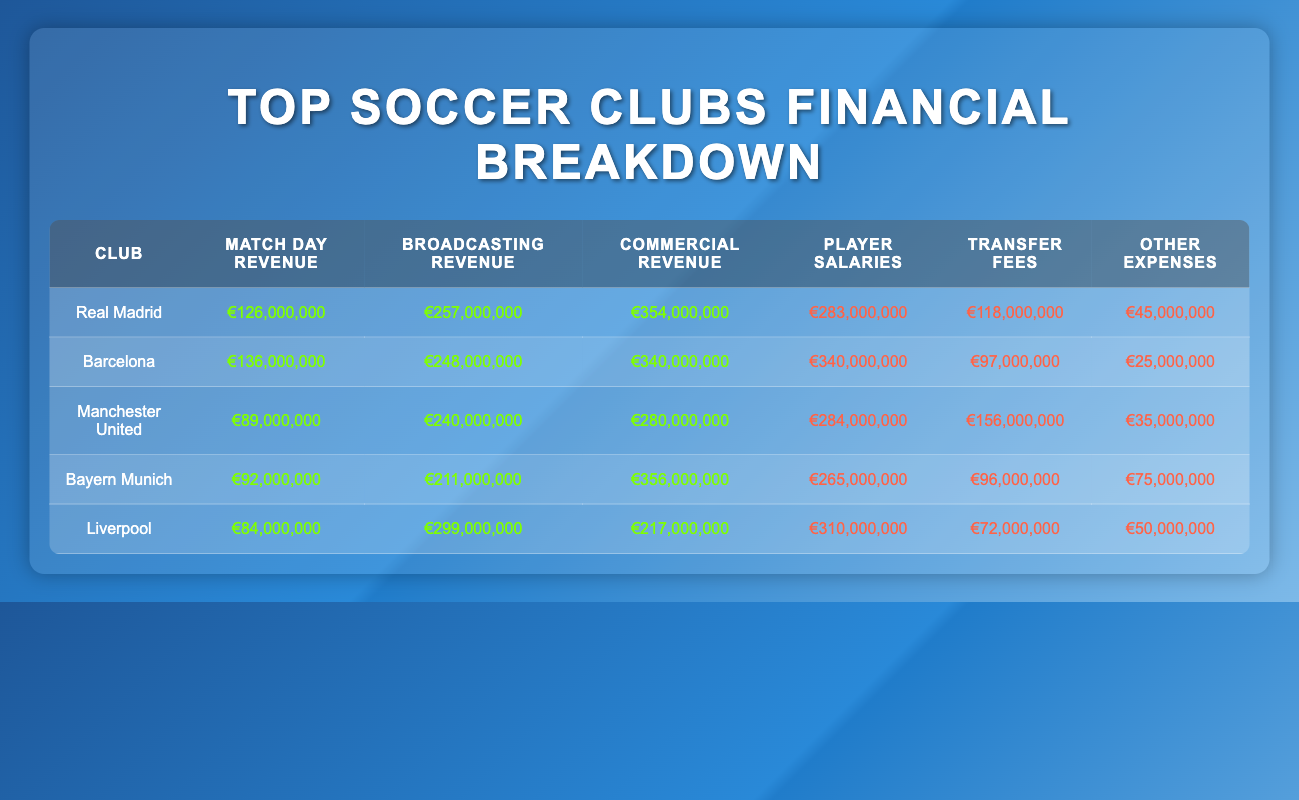What is the match day revenue for Barcelona? The table shows that Barcelona's match day revenue is listed directly under the relevant column. Looking at the row for Barcelona, the match day revenue is €136,000,000.
Answer: €136,000,000 Which club has the highest broadcasting revenue? By comparing the broadcasting revenue figures for all clubs in the table, Bayern Munich's broadcasting revenue is €211,000,000, while the others are lower: Real Madrid at €257,000,000 and Barcelona at €248,000,000. Therefore, Real Madrid has the highest broadcasting revenue.
Answer: €257,000,000 What is the total player salaries for all clubs combined? To calculate the total player salaries, we sum the player salaries of all clubs: Real Madrid €283,000,000 + Barcelona €340,000,000 + Manchester United €284,000,000 + Bayern Munich €265,000,000 + Liverpool €310,000,000. This totals to €1,482,000,000.
Answer: €1,482,000,000 Does Manchester United spend more on transfer fees than Bayern Munich? We need to compare the transfer fees for both clubs as per the table. Manchester United has transfer fees totaling €156,000,000, while Bayern Munich has €96,000,000. Since €156,000,000 is greater than €96,000,000, it is true that Manchester United spends more on transfer fees.
Answer: Yes What is the difference in commercial revenue between Real Madrid and Liverpool? First, we find the commercial revenue for both clubs from the table: Real Madrid €354,000,000 and Liverpool €217,000,000. To find the difference, we subtract the Liverpool figure from the Real Madrid figure: €354,000,000 - €217,000,000 = €137,000,000.
Answer: €137,000,000 Which club has the lowest match day revenue? We need to look at the match day revenue column and identify the lowest figure from the clubs listed. Liverpool's match day revenue is €84,000,000, which is lower than the rest: Real Madrid €126,000,000, Barcelona €136,000,000, Manchester United €89,000,000, and Bayern Munich €92,000,000. Therefore, Liverpool has the lowest match day revenue.
Answer: €84,000,000 If Barcelona increased their broadcasting revenue by 10%, what would be the new amount? First, we find Barcelona's current broadcasting revenue from the table, which is €248,000,000. To calculate a 10% increase, we multiply €248,000,000 by 0.10, which gives us €24,800,000. Adding this to the original value: €248,000,000 + €24,800,000 = €272,800,000.
Answer: €272,800,000 What percentage of total expenditure does Manchester United allocate to player salaries? First, we find Manchester United's total expenditure: Player Salaries €284,000,000 + Transfer Fees €156,000,000 + Other Expenses €35,000,000 = €475,000,000. The player salaries are €284,000,000. Now we compute the percentage: (€284,000,000 / €475,000,000) * 100 = 59.79%.
Answer: 59.79% Is it true that Liverpool has the highest player salaries among the clubs listed? Looking at the player salaries in the table, Liverpool has €310,000,000, while the other clubs have: Real Madrid €283,000,000, Barcelona €340,000,000, Manchester United €284,000,000, and Bayern Munich €265,000,000. Since €340,000,000 (Barcelona) is more than €310,000,000, Liverpool does not have the highest player salaries.
Answer: No 